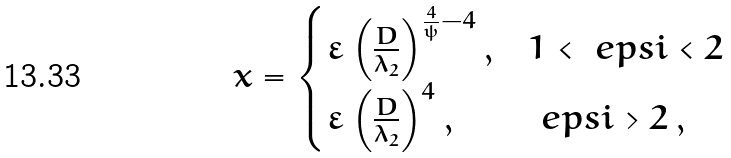<formula> <loc_0><loc_0><loc_500><loc_500>x = \begin{cases} \varepsilon \left ( \frac { D } { \lambda _ { 2 } } \right ) ^ { \frac { 4 } { \psi } - 4 } , & 1 < \ e p s i < 2 \\ \varepsilon \left ( \frac { D } { \lambda _ { 2 } } \right ) ^ { 4 } , & \ e p s i > 2 \, , \end{cases}</formula> 